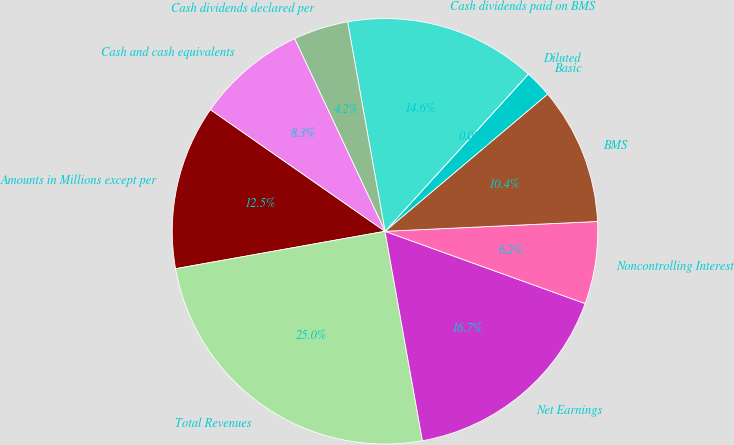Convert chart. <chart><loc_0><loc_0><loc_500><loc_500><pie_chart><fcel>Amounts in Millions except per<fcel>Total Revenues<fcel>Net Earnings<fcel>Noncontrolling Interest<fcel>BMS<fcel>Basic<fcel>Diluted<fcel>Cash dividends paid on BMS<fcel>Cash dividends declared per<fcel>Cash and cash equivalents<nl><fcel>12.5%<fcel>25.0%<fcel>16.67%<fcel>6.25%<fcel>10.42%<fcel>2.08%<fcel>0.0%<fcel>14.58%<fcel>4.17%<fcel>8.33%<nl></chart> 